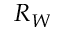<formula> <loc_0><loc_0><loc_500><loc_500>R _ { W }</formula> 